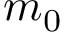<formula> <loc_0><loc_0><loc_500><loc_500>m _ { 0 }</formula> 